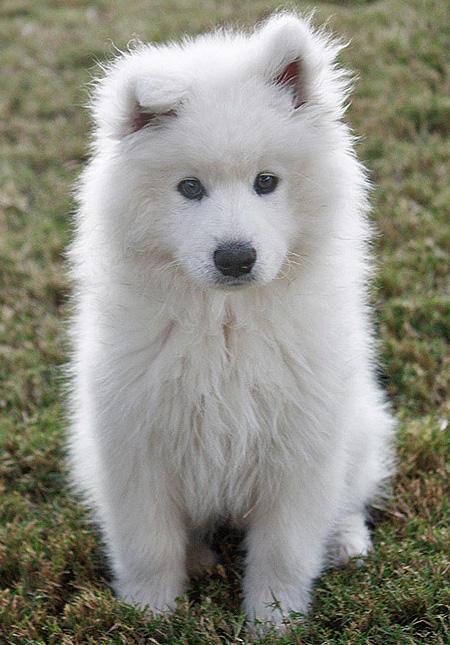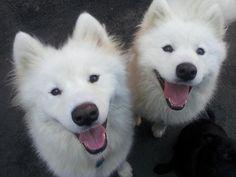The first image is the image on the left, the second image is the image on the right. Analyze the images presented: Is the assertion "The right image contains at least one white dog with its tongue exposed." valid? Answer yes or no. Yes. The first image is the image on the left, the second image is the image on the right. Assess this claim about the two images: "The combined images include two white dogs with smiling opened mouths showing pink tongues.". Correct or not? Answer yes or no. Yes. 